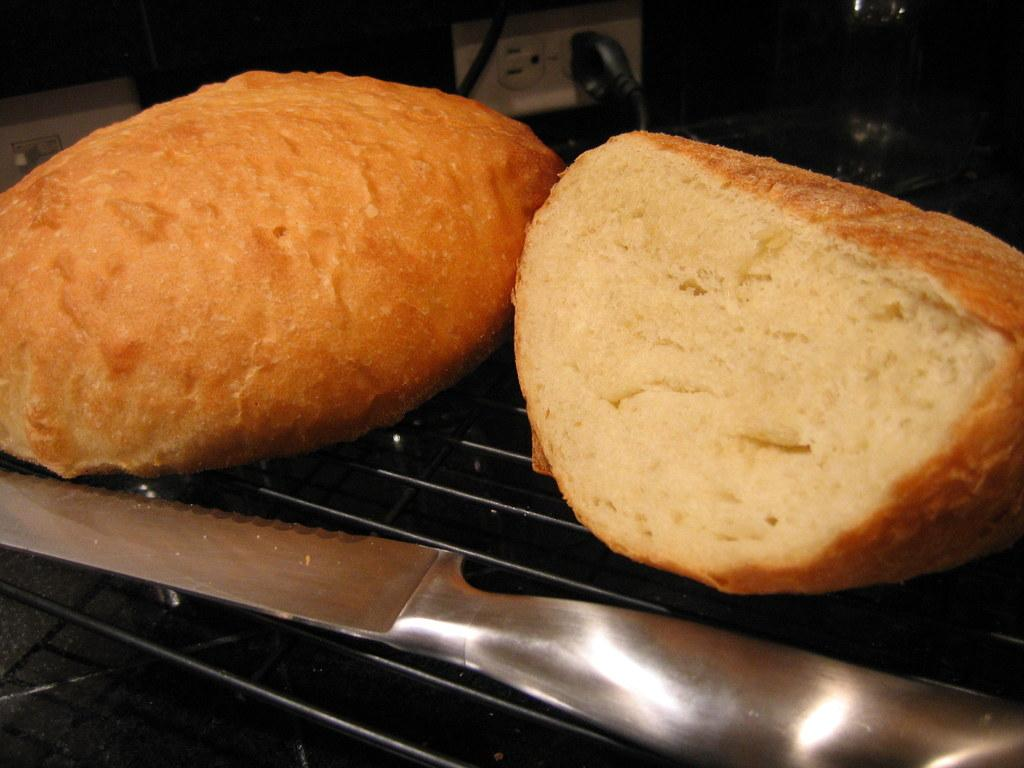What is on the grill in the image? There are two buns on a grill in the image. What is located near the buns on the grill? There is a knife beside the buns in the image. What type of creature is standing on the grill with the buns in the image? There is no creature present on the grill with the buns in the image. How much sugar is sprinkled on the buns in the image? There is no sugar visible on the buns in the image. 